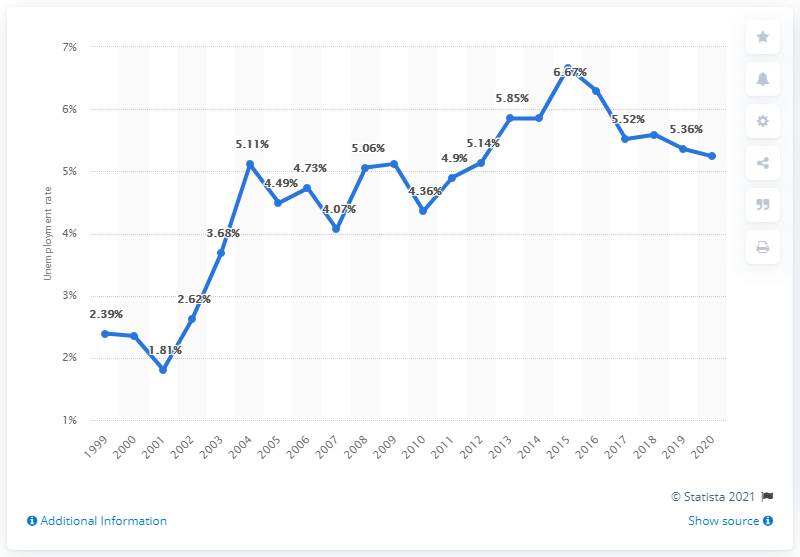Give some essential details in this illustration. In 2020, the unemployment rate in Luxembourg was 5.24%. 